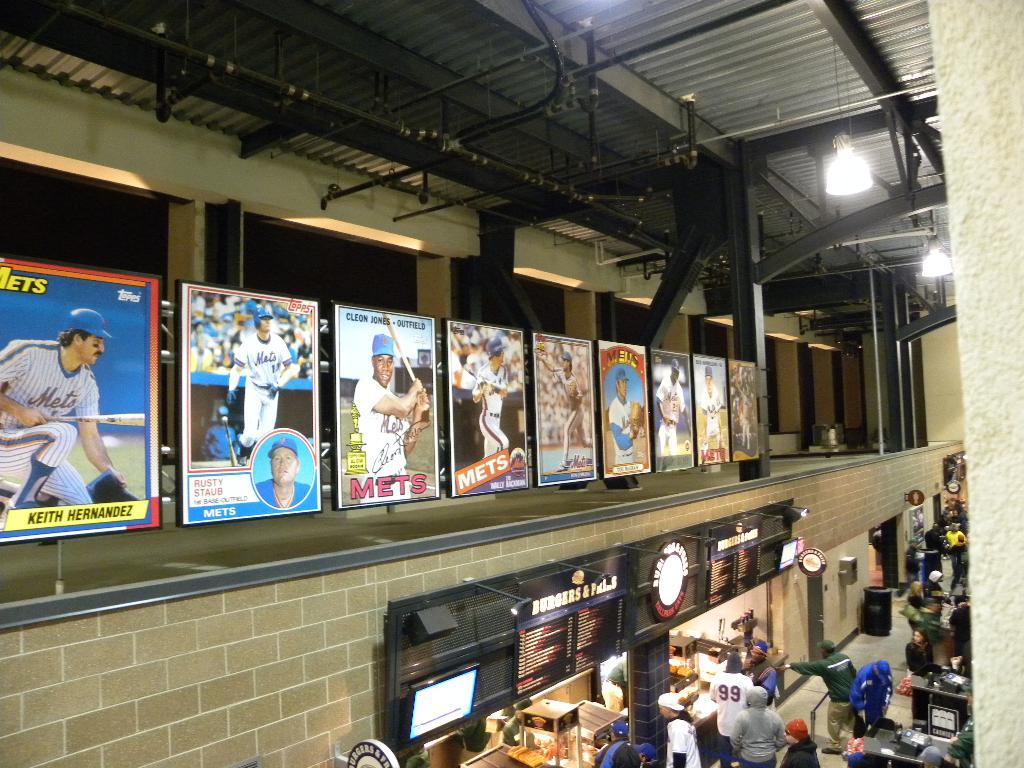Who is the player on the first poster on the left?
Offer a terse response. Keith hernandez. What team are these posters for?
Provide a short and direct response. Mets. 